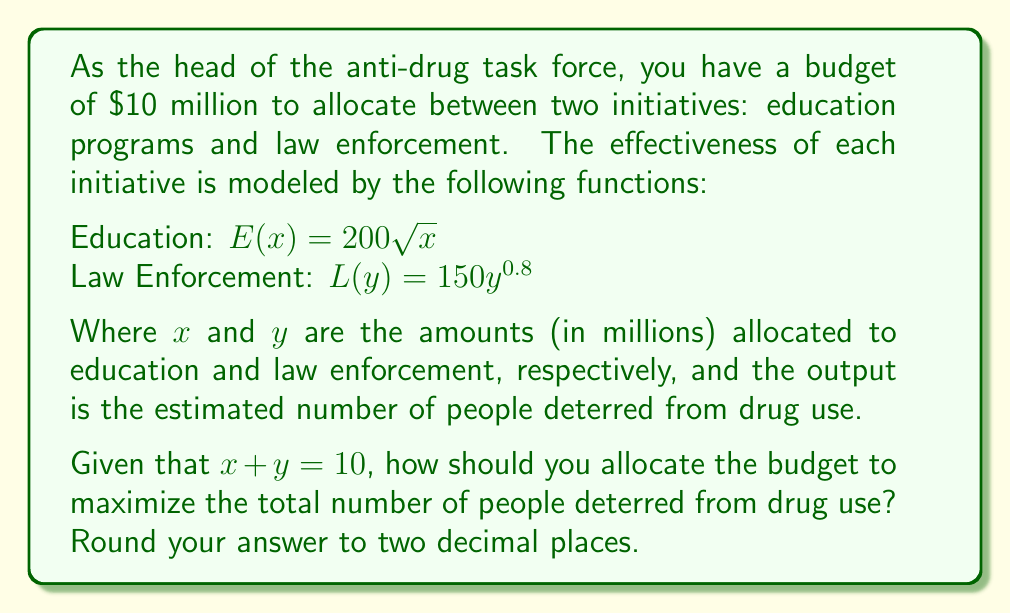Teach me how to tackle this problem. To solve this optimization problem, we'll use the method of Lagrange multipliers:

1) Let's define our objective function:
   $f(x,y) = E(x) + L(y) = 200\sqrt{x} + 150y^{0.8}$

2) Our constraint is:
   $g(x,y) = x + y - 10 = 0$

3) We form the Lagrangian:
   $\mathcal{L}(x,y,\lambda) = 200\sqrt{x} + 150y^{0.8} + \lambda(x + y - 10)$

4) Now, we take partial derivatives and set them to zero:
   
   $\frac{\partial \mathcal{L}}{\partial x} = \frac{100}{\sqrt{x}} + \lambda = 0$
   
   $\frac{\partial \mathcal{L}}{\partial y} = 120y^{-0.2} + \lambda = 0$
   
   $\frac{\partial \mathcal{L}}{\partial \lambda} = x + y - 10 = 0$

5) From the first two equations:
   $\frac{100}{\sqrt{x}} = 120y^{-0.2}$

6) This can be rewritten as:
   $\frac{25}{3} = (\frac{y}{x})^{0.2}$

7) Taking both sides to the power of 5:
   $(\frac{25}{3})^5 = \frac{y}{x}$

8) Simplifying:
   $y = \frac{3052}{243}x$

9) Substituting this into our constraint equation:
   $x + \frac{3052}{243}x = 10$
   
   $\frac{3295}{243}x = 10$
   
   $x = \frac{2430}{3295} \approx 0.7375$

10) Therefore:
    $y = 10 - x \approx 9.2625$

11) To verify this is a maximum, we can check the second derivatives, which confirm this is indeed a maximum point.
Answer: Allocate $0.74 million to education programs and $9.26 million to law enforcement. 